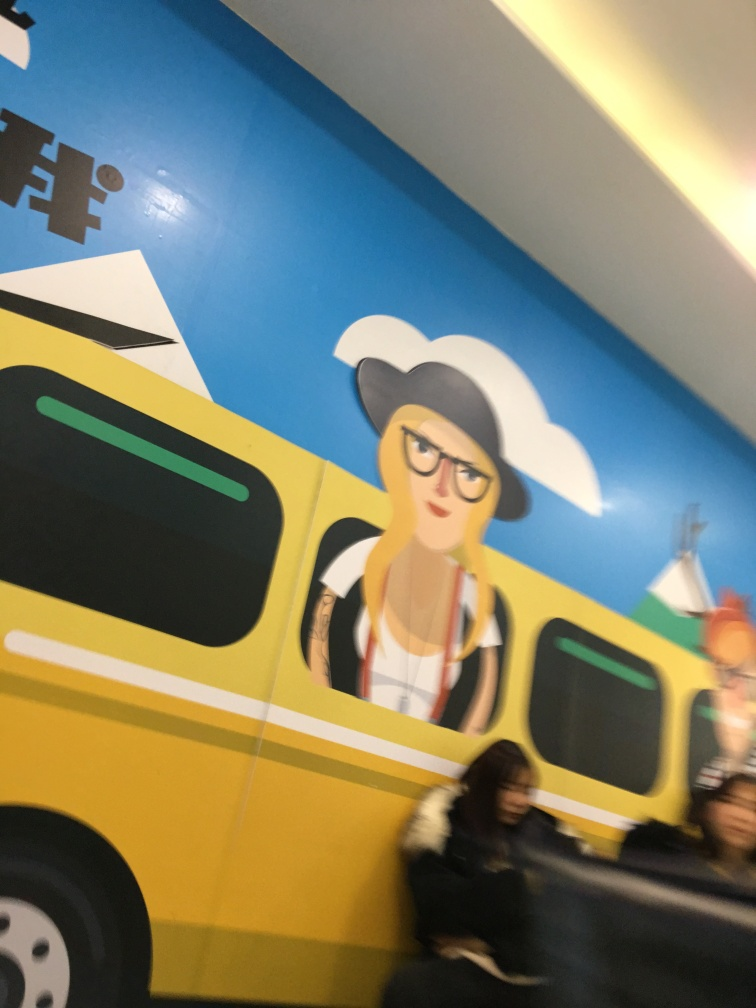Can you tell me about the probable setting or context where this image was taken? This image seems to have been taken in an indoor space, possibly a public area or transit location, evidenced by the presence of a painted wall mural which includes a stylized yellow vehicle, perhaps a bus, and an illustrated character with urban attire that might suggest a city or metropolitan theme. 